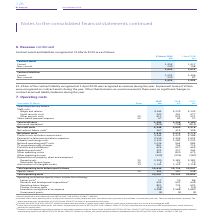According to Bt Group Plc's financial document, How much contract liability was recognised at 1 April 2018? £1,216m of the contract liability recognised at 1 April 2018. The document states: "£1,216m of the contract liability recognised at 1 April 2018 was recognised as revenue during the year. Impairment losses of £36m were recognised on c..." Also, How much Impairment losses was recognised at 2018? Impairment losses of £36m were recognised on contract assets during the year.. The document states: "il 2018 was recognised as revenue during the year. Impairment losses of £36m were recognised on contract assets during the year. Other than business-a..." Also, What was the current contract assets at 2019? According to the financial document, 1,353 (in millions). The relevant text states: "Contract assets Current 1,353 1,417 Non-current 249 198..." Also, can you calculate: What is the change in Contract assets: Current from 31 March 2019 to 1 April 2018? Based on the calculation: 1,353-1,417, the result is -64 (in millions). This is based on the information: "Contract assets Current 1,353 1,417 Non-current 249 198 Contract assets Current 1,353 1,417 Non-current 249 198..." The key data points involved are: 1,353, 1,417. Also, can you calculate: What is the change in Contract assets: Non-Current from 31 March 2019 to 1 April 2018? Based on the calculation: 249-198, the result is 51 (in millions). This is based on the information: "ntract assets Current 1,353 1,417 Non-current 249 198 Contract assets Current 1,353 1,417 Non-current 249 198..." The key data points involved are: 198, 249. Also, can you calculate: What is the change in Contract liabilities: Current from 31 March 2019 to 1 April 2018? Based on the calculation: 1,225-1,406, the result is -181 (in millions). This is based on the information: "Contract liabilities Current 1,225 1,406 Non-current 200 87 Contract liabilities Current 1,225 1,406 Non-current 200 87..." The key data points involved are: 1,225, 1,406. 